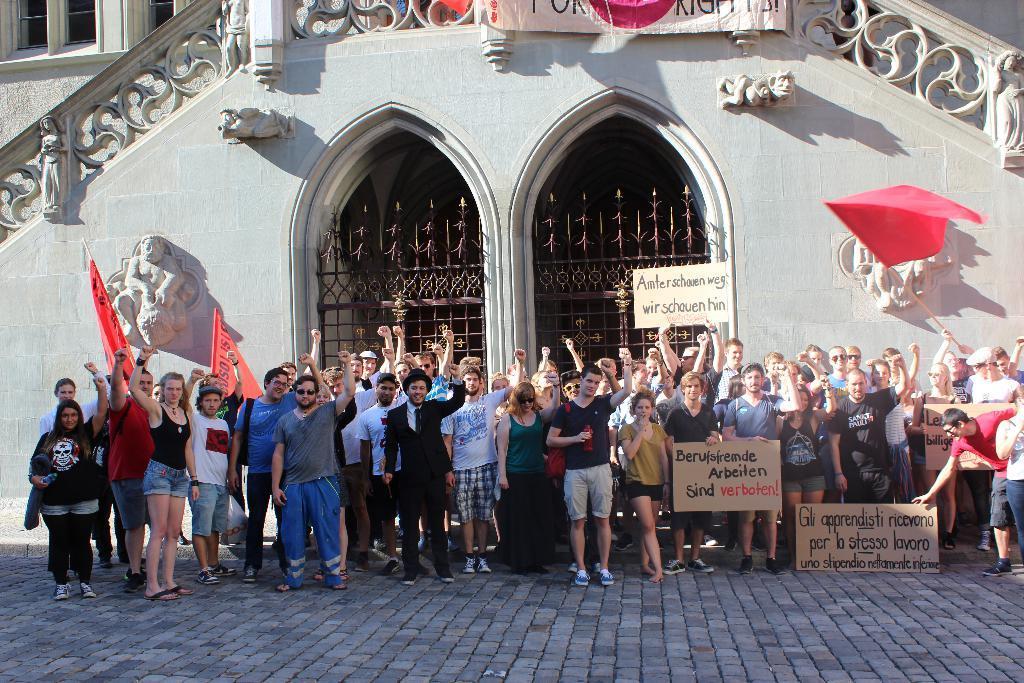Could you give a brief overview of what you see in this image? In this image I can see the ground and number of persons are standing on the ground. I can see few of them are holding boards and few are holding flags in their hands. In the background I can see a building, the railing, few statues to the buildings, two metal gates and a banner. 